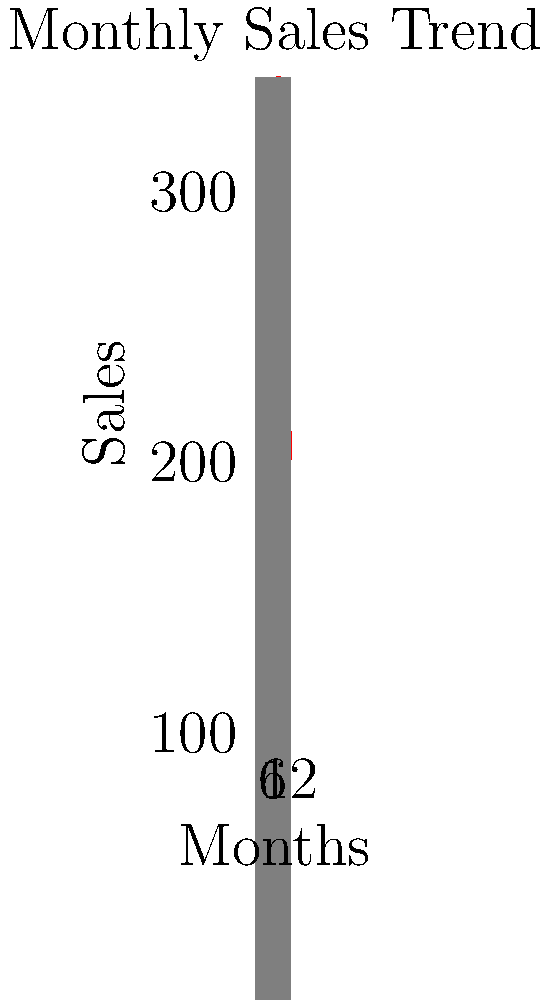Based on the time series graph of monthly sales for a popular health supplement, forecast the inventory needs for the next three months using a simple moving average model. Assume the moving average window is 3 months. What is the forecasted sales volume for the 13th month? To forecast inventory needs using a simple moving average model with a 3-month window:

1. Identify the last 3 months of sales data:
   Month 10: 280
   Month 11: 240
   Month 12: 200

2. Calculate the simple moving average:
   $$ SMA = \frac{280 + 240 + 200}{3} = \frac{720}{3} = 240 $$

3. The forecast for the 13th month is the calculated SMA value.

4. For the following months:
   - 14th month: Use data from months 11, 12, and 13 (forecast)
   - 15th month: Use data from months 12, 13 (forecast), and 14 (forecast)

5. This method assumes that recent trends will continue, which may not always be accurate. In practice, more sophisticated models like exponential smoothing or ARIMA might be used for better accuracy.

6. As an entrepreneur, you should also consider:
   - Seasonal trends (e.g., higher sales in summer months)
   - Marketing campaigns that might affect future sales
   - Product shelf life and storage costs
   - Lead time for restocking inventory

7. Regularly update your forecast as new data becomes available to improve accuracy.
Answer: 240 units 